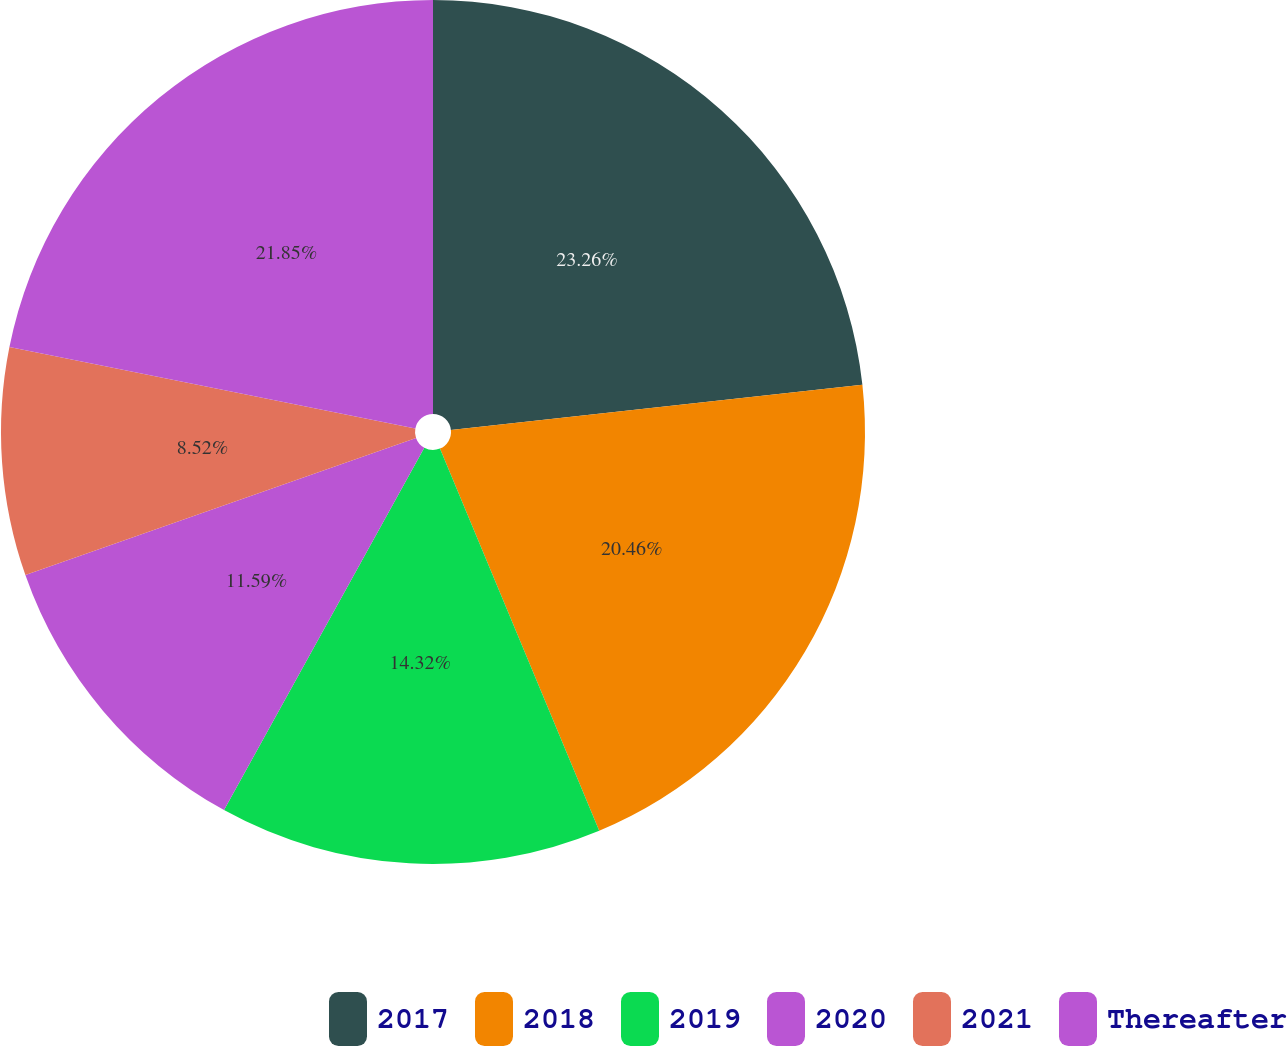<chart> <loc_0><loc_0><loc_500><loc_500><pie_chart><fcel>2017<fcel>2018<fcel>2019<fcel>2020<fcel>2021<fcel>Thereafter<nl><fcel>23.25%<fcel>20.46%<fcel>14.32%<fcel>11.59%<fcel>8.52%<fcel>21.85%<nl></chart> 